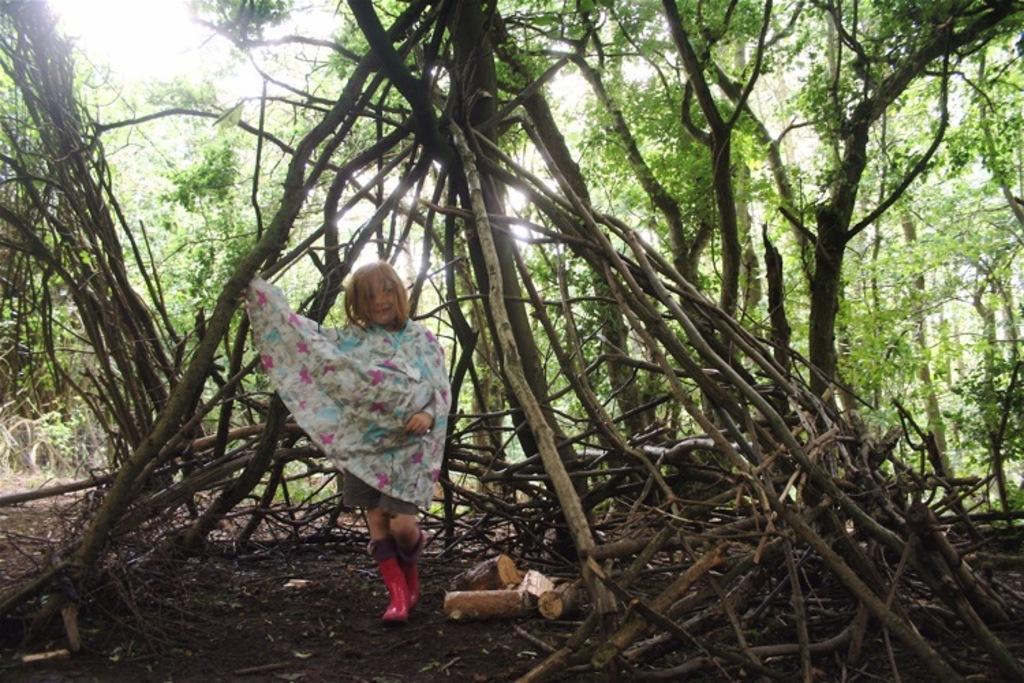Can you describe this image briefly? In the foreground of the picture we can see wooden logs, soil and a girl. In the background there are trees. 